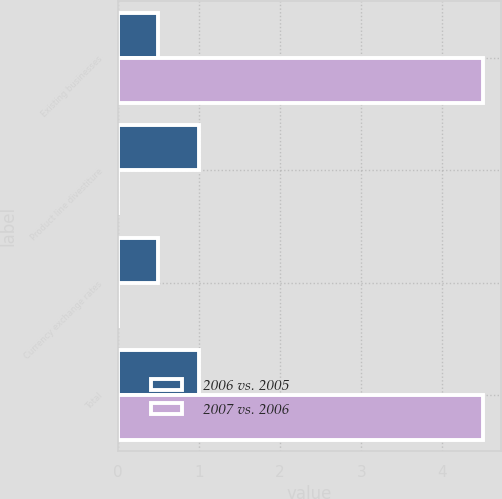<chart> <loc_0><loc_0><loc_500><loc_500><stacked_bar_chart><ecel><fcel>Existing businesses<fcel>Product line divestiture<fcel>Currency exchange rates<fcel>Total<nl><fcel>2006 vs. 2005<fcel>0.5<fcel>1<fcel>0.5<fcel>1<nl><fcel>2007 vs. 2006<fcel>4.5<fcel>0<fcel>0<fcel>4.5<nl></chart> 